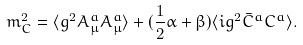<formula> <loc_0><loc_0><loc_500><loc_500>m _ { C } ^ { 2 } = \langle g ^ { 2 } A _ { \mu } ^ { a } A _ { \mu } ^ { a } \rangle + ( \frac { 1 } { 2 } \alpha + \beta ) \langle i g ^ { 2 } \bar { C } ^ { a } C ^ { a } \rangle .</formula> 